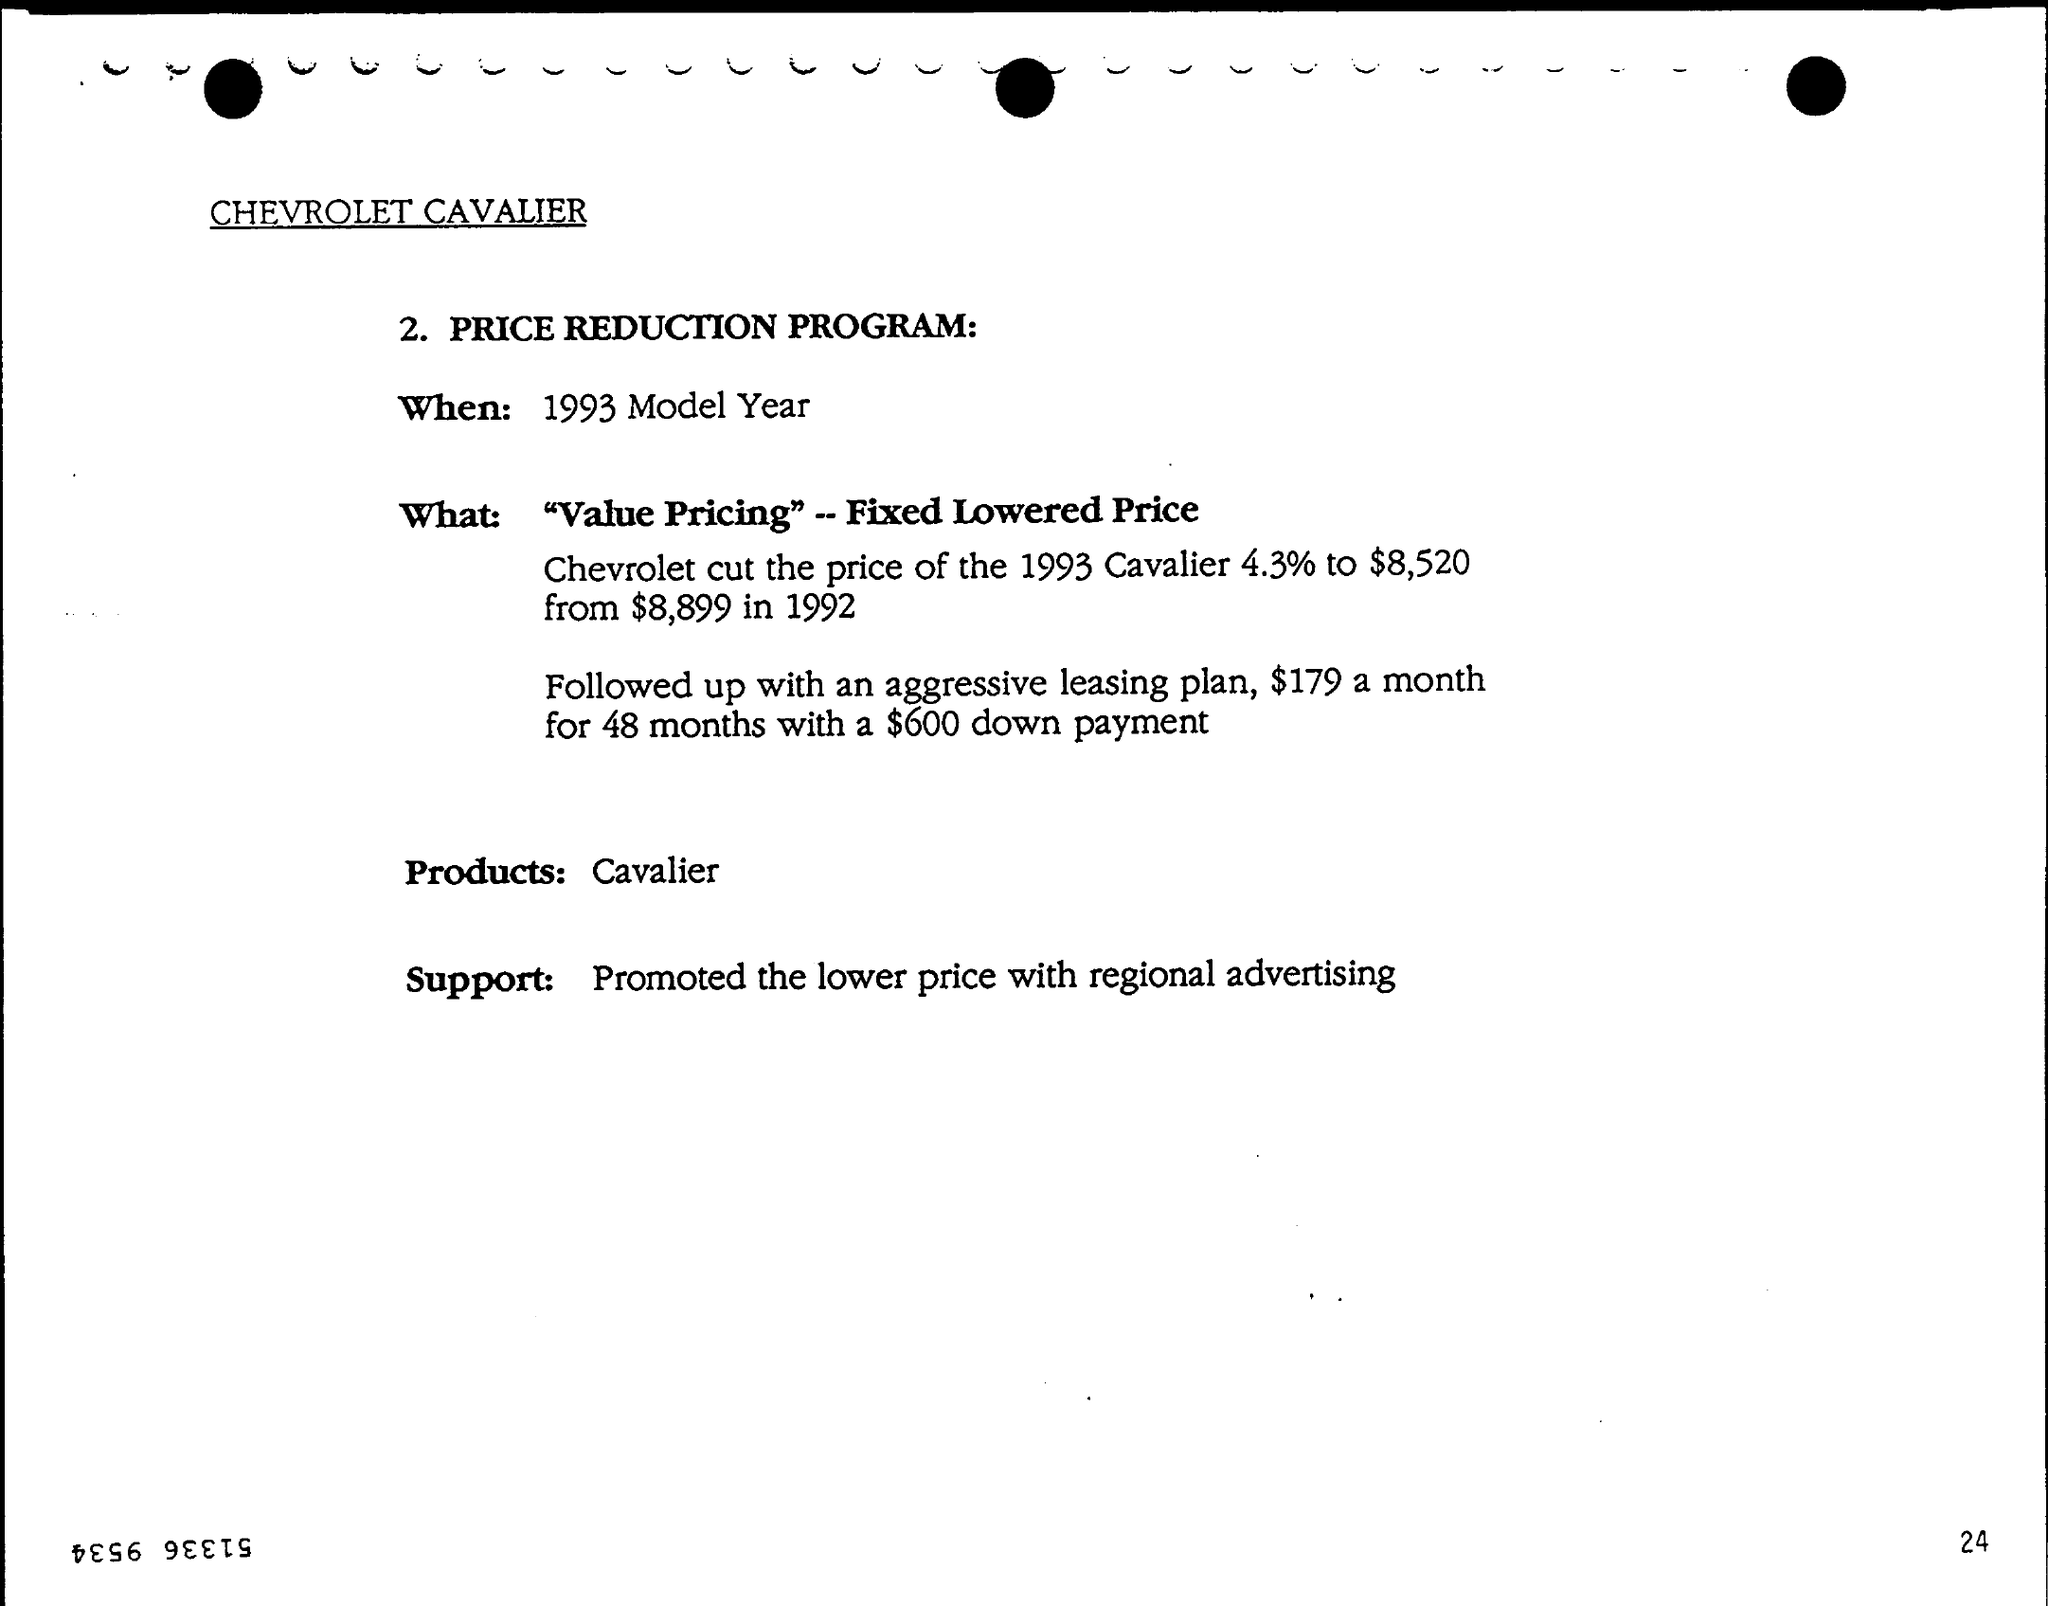Indicate a few pertinent items in this graphic. We promoted the lower price through regional advertising to generate support. The brand Chevrolet Cavalier is mentioned. The PRICE REDUCTION PROGRAM will be offered for 1993 Model Year vehicles. 